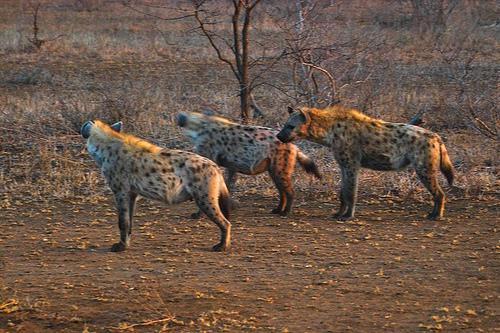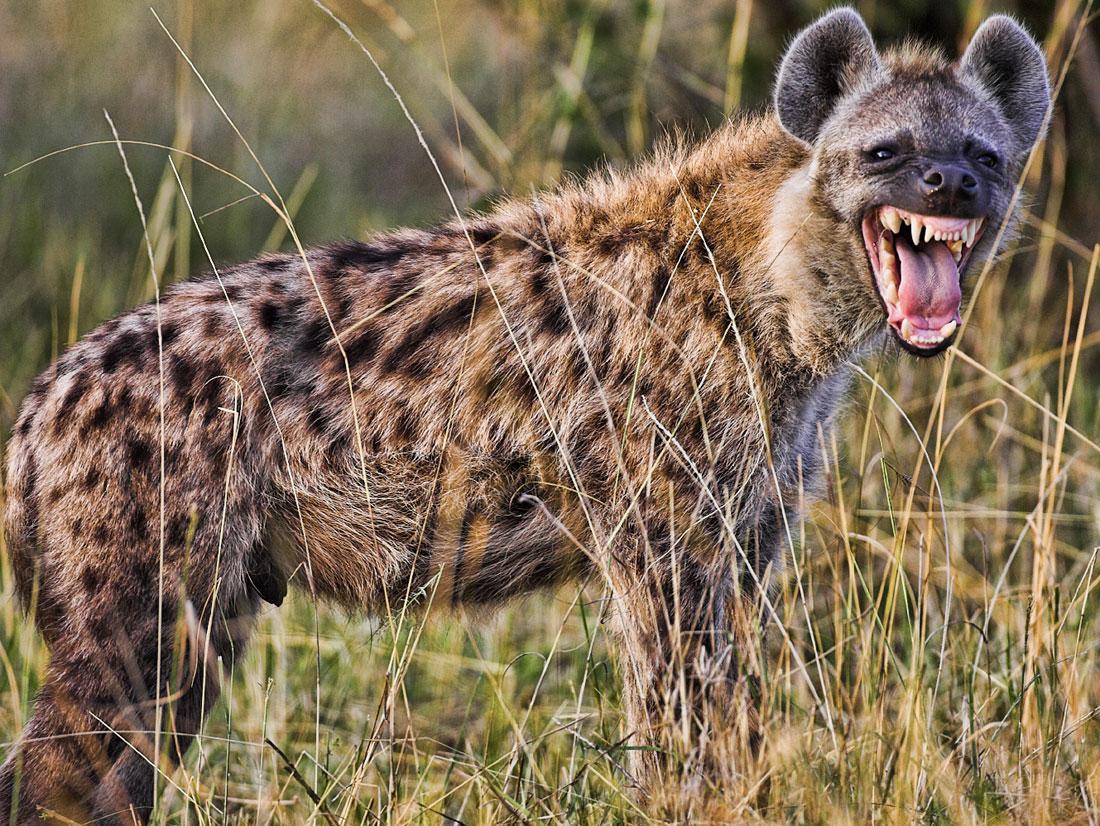The first image is the image on the left, the second image is the image on the right. Evaluate the accuracy of this statement regarding the images: "In one of the image the pack of hyenas are moving right.". Is it true? Answer yes or no. No. The first image is the image on the left, the second image is the image on the right. Examine the images to the left and right. Is the description "At least one image has a  single tan and black hyena opening its mouth showing its teeth." accurate? Answer yes or no. Yes. 